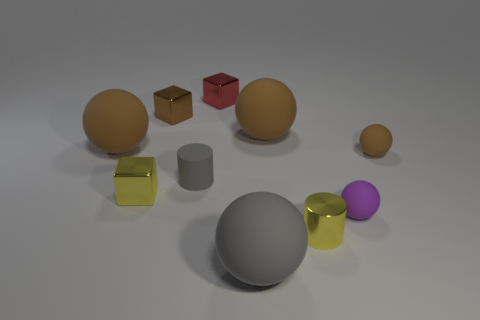Subtract all purple cylinders. How many brown balls are left? 3 Subtract all gray balls. How many balls are left? 4 Subtract 1 balls. How many balls are left? 4 Subtract all purple matte spheres. How many spheres are left? 4 Subtract all red spheres. Subtract all red cylinders. How many spheres are left? 5 Subtract all cylinders. How many objects are left? 8 Subtract all green shiny blocks. Subtract all large brown matte objects. How many objects are left? 8 Add 2 small brown cubes. How many small brown cubes are left? 3 Add 10 big rubber cylinders. How many big rubber cylinders exist? 10 Subtract 1 brown blocks. How many objects are left? 9 